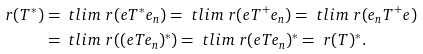<formula> <loc_0><loc_0><loc_500><loc_500>\ r ( T ^ { * } ) & = \ t l i m \ r ( e T ^ { * } e _ { n } ) = \ t l i m \ r ( e T ^ { + } e _ { n } ) = \ t l i m \ r ( e _ { n } T ^ { + } e ) \\ & = \ t l i m \ r ( ( e T e _ { n } ) ^ { * } ) = \ t l i m \ r ( e T e _ { n } ) ^ { * } = \ r ( T ) ^ { * } .</formula> 